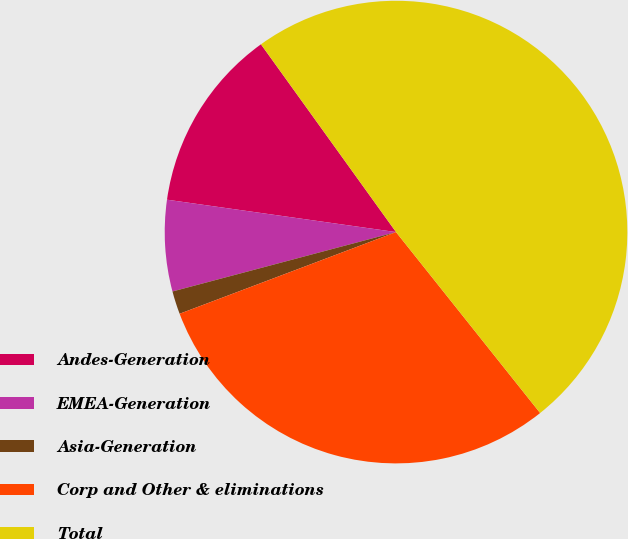<chart> <loc_0><loc_0><loc_500><loc_500><pie_chart><fcel>Andes-Generation<fcel>EMEA-Generation<fcel>Asia-Generation<fcel>Corp and Other & eliminations<fcel>Total<nl><fcel>12.84%<fcel>6.37%<fcel>1.61%<fcel>29.96%<fcel>49.22%<nl></chart> 